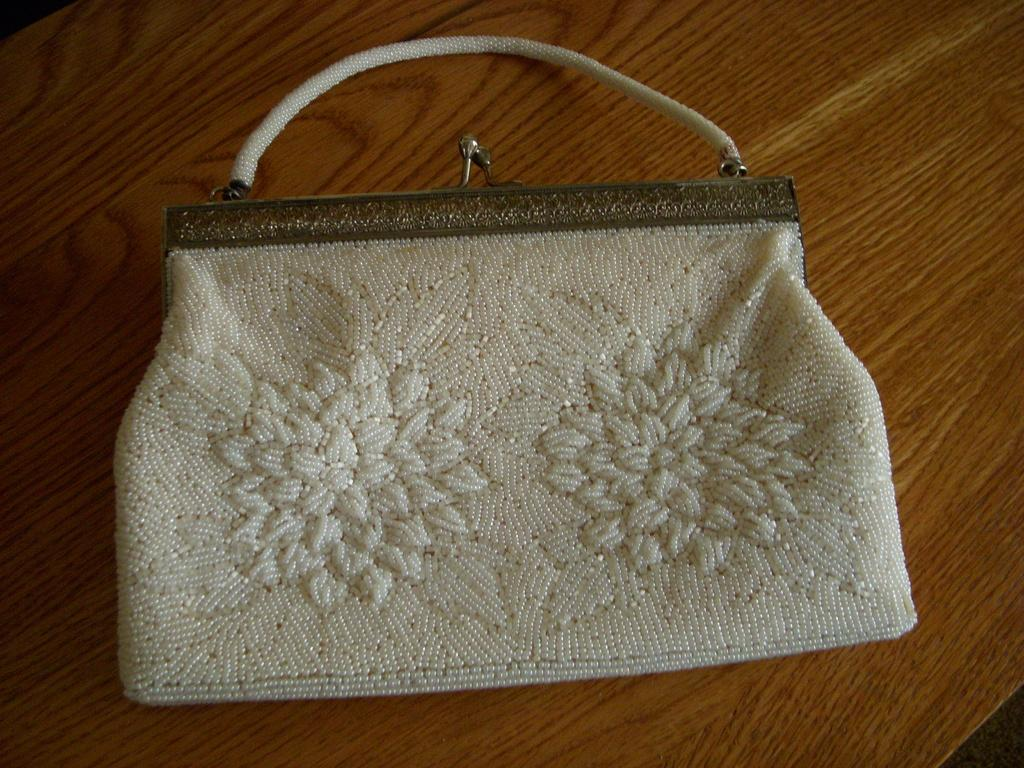What color is the handbag in the image? The handbag in the image is white. How many clovers are growing inside the handbag in the image? There are no clovers present in the image, as it features a white color handbag. What is the cause of the handbag's existence in the image? The cause of the handbag's existence in the image cannot be determined from the image itself, as it only shows the handbag and does not provide any context or explanation for its presence. 